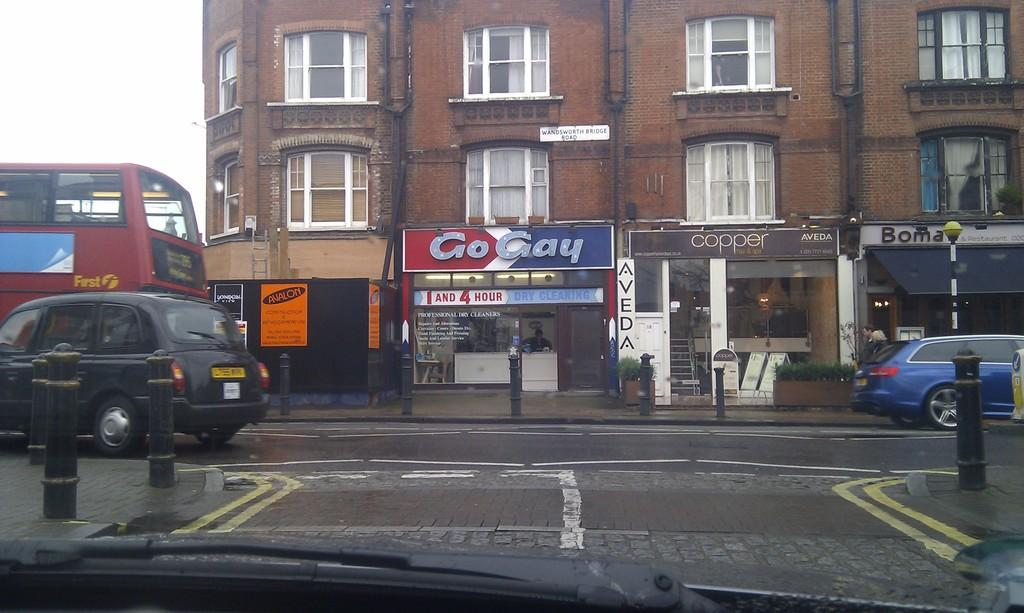Provide a one-sentence caption for the provided image. City buildings with a Go Gay store underneath. 